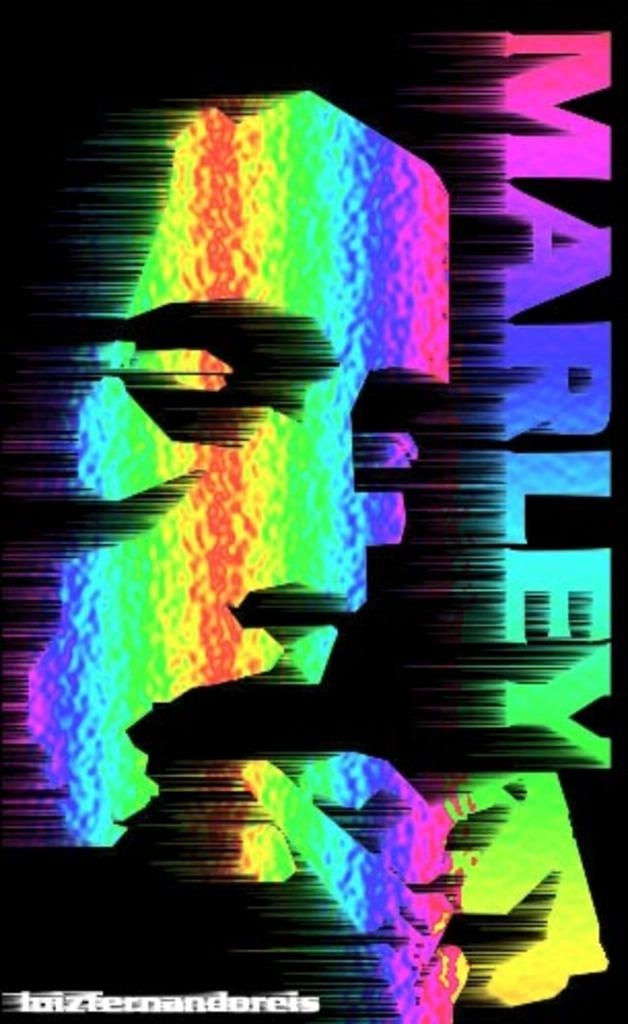<image>
Summarize the visual content of the image. A multicolored poster that has the writing Marley at the top. 